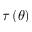<formula> <loc_0><loc_0><loc_500><loc_500>\tau \left ( \theta \right )</formula> 